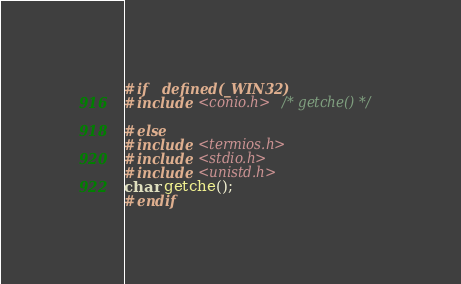<code> <loc_0><loc_0><loc_500><loc_500><_C_>

#if   defined(_WIN32)
#include <conio.h> /* getche() */

#else
#include <termios.h>
#include <stdio.h>
#include <unistd.h>
char getche();
#endif 
</code> 